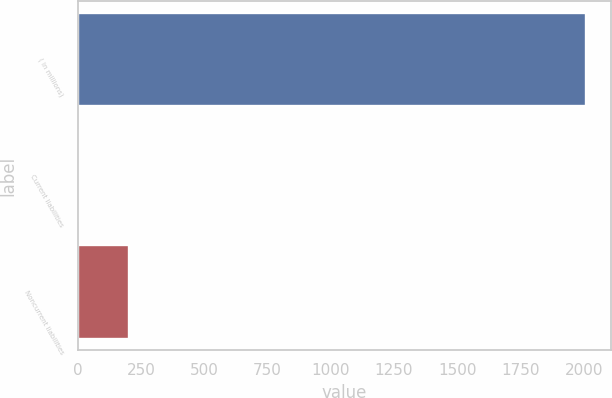Convert chart. <chart><loc_0><loc_0><loc_500><loc_500><bar_chart><fcel>( in millions)<fcel>Current liabilities<fcel>Noncurrent liabilities<nl><fcel>2008<fcel>0.9<fcel>201.61<nl></chart> 